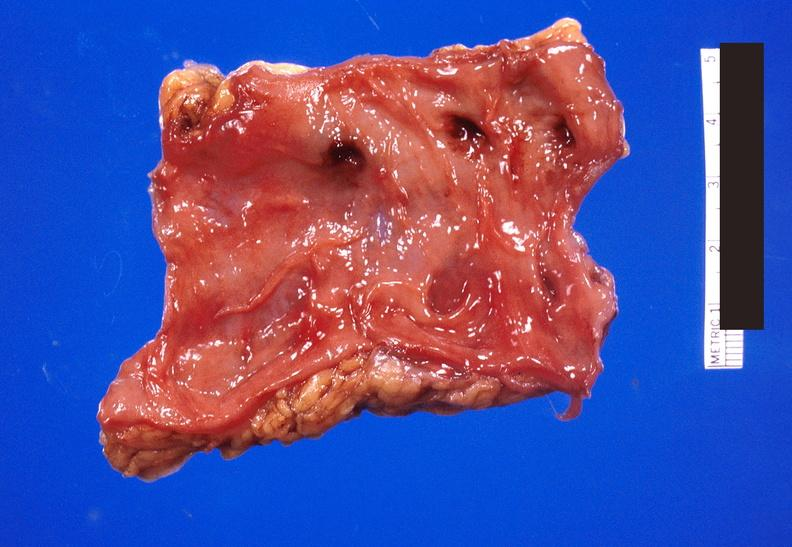does this image show colon polyposis?
Answer the question using a single word or phrase. Yes 